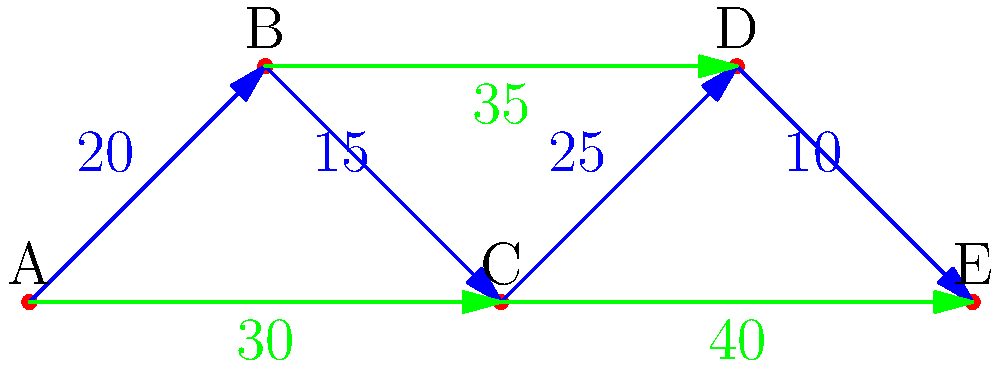The directed graph above represents migrant flows between five European countries (A, B, C, D, and E) in thousands. Blue arrows represent neighboring country flows, while green arrows represent non-neighboring country flows. What is the maximum number of migrants that could potentially move from country A to country E without violating the capacity of any single path? To solve this problem, we need to find the maximum flow from A to E. We'll use the concept of network flow and the Ford-Fulkerson algorithm:

1. Identify all possible paths from A to E:
   Path 1: A → B → C → D → E
   Path 2: A → B → D → E
   Path 3: A → C → D → E
   Path 4: A → C → E

2. Calculate the capacity of each path:
   Path 1: min(20, 15, 25, 10) = 10
   Path 2: min(20, 35, 10) = 10
   Path 3: min(30, 25, 10) = 10
   Path 4: min(30, 40) = 30

3. The maximum flow is the sum of the flows through all paths:
   10 + 10 + 10 + 30 = 60

Therefore, the maximum number of migrants that could potentially move from country A to country E is 60,000.
Answer: 60,000 migrants 